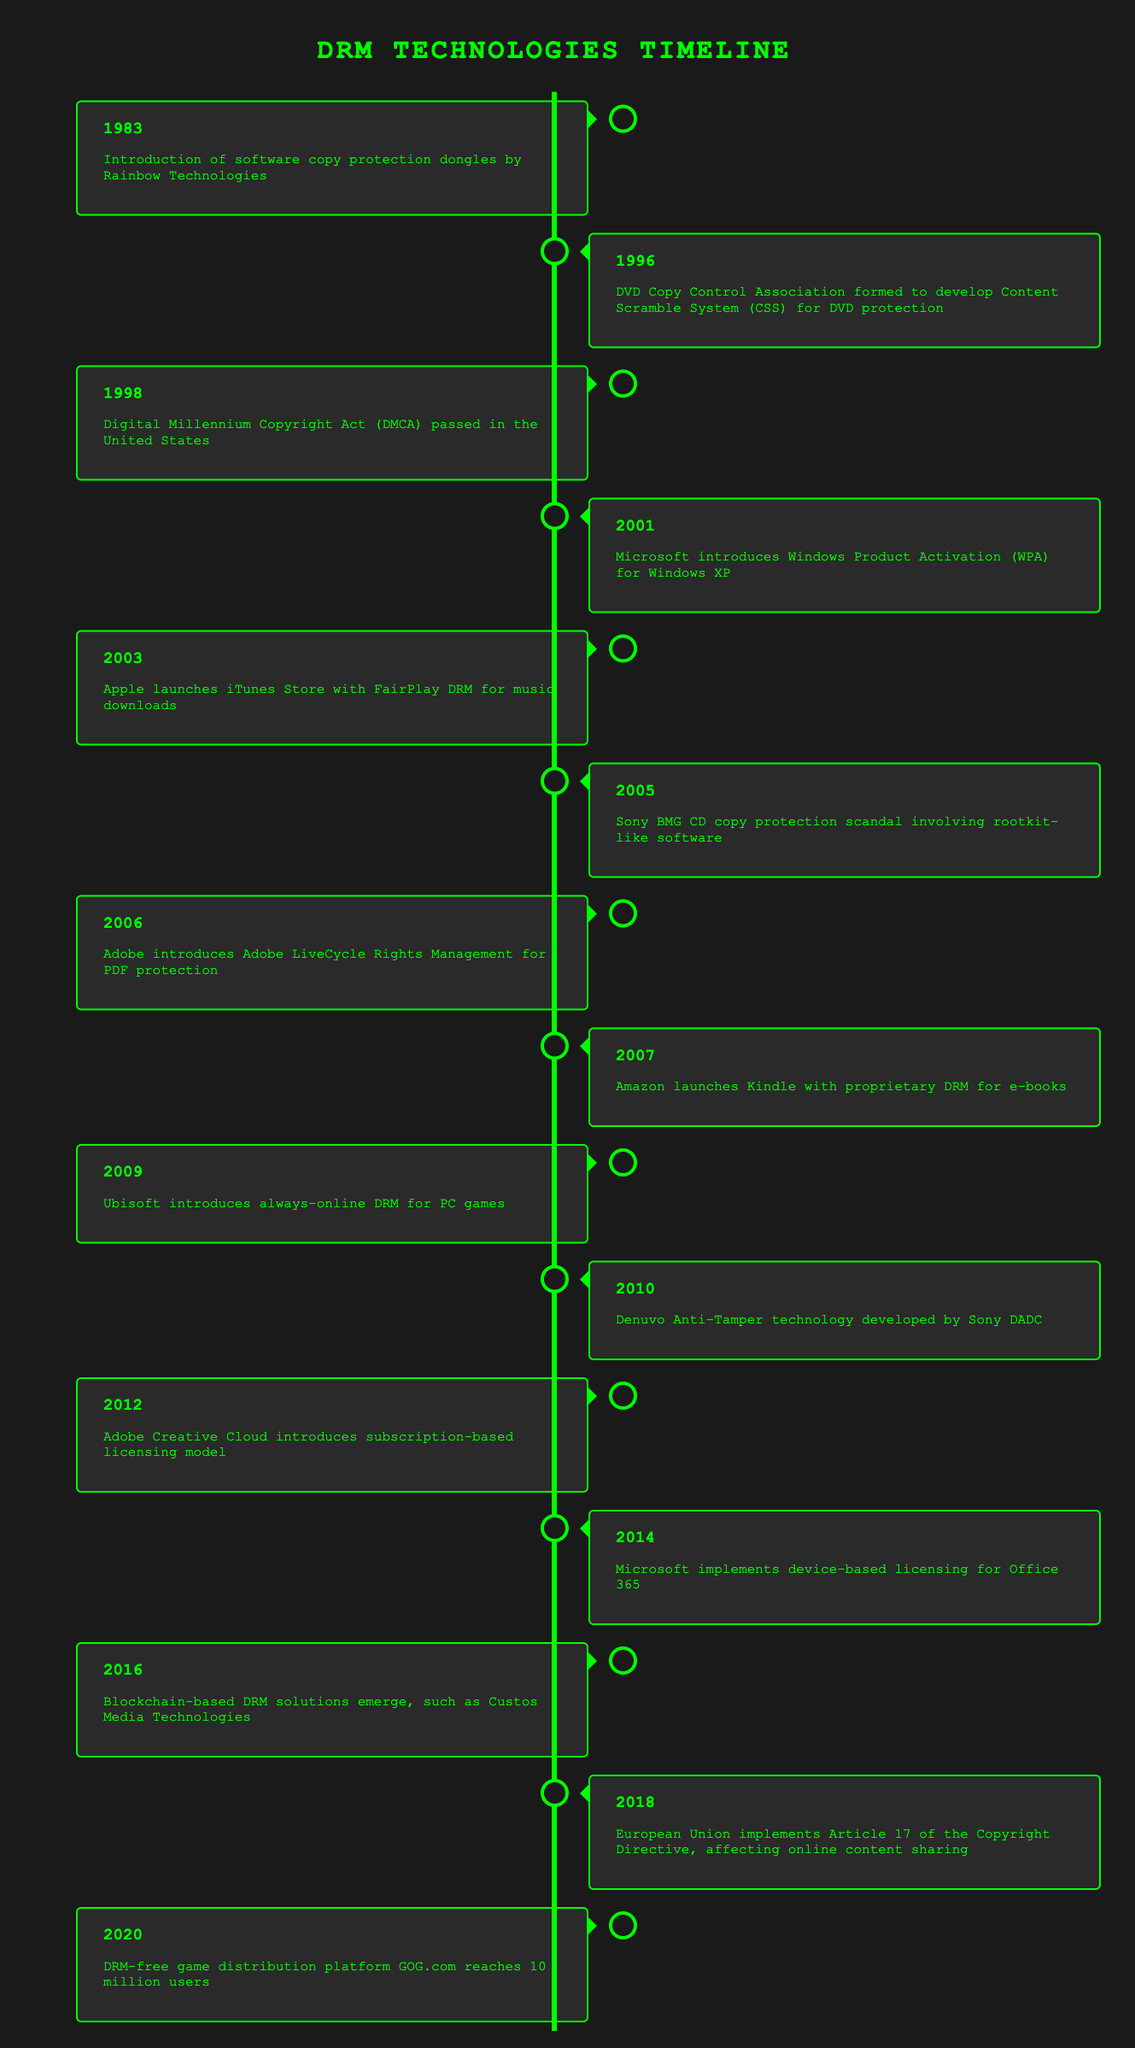What year was the Digital Millennium Copyright Act (DMCA) passed in the United States? The year the DMCA was passed is explicitly stated in the row for that event. It shows 1998 as the year for the event in which the DMCA was enacted, according to the timeline table.
Answer: 1998 What company introduced Windows Product Activation (WPA) for Windows XP? The event describes "Microsoft introduces Windows Product Activation (WPA) for Windows XP" and indicates that Microsoft is the company responsible for this development, as captured in the timeline.
Answer: Microsoft Which event occurred first, the introduction of DRM for e-books by Amazon or the introduction of Adobe LiveCycle Rights Management? Looking at the years associated with the two events, Adobe LiveCycle Rights Management was introduced in 2006 while Amazon’s DRM for e-books was launched in 2007. Since 2006 is earlier than 2007, Adobe's event occurred first.
Answer: Adobe LiveCycle Rights Management How many years passed between the introduction of FairPlay DRM by Apple in 2003 and the launch of the Kindle by Amazon in 2007? To find the number of years between these two events, subtract the earlier year from the later year: 2007 - 2003 = 4. This calculation indicates that 4 years passed between these events.
Answer: 4 Did the European Union's implementation of Article 17 of the Copyright Directive occur before or after GOG.com reached 10 million users? According to the timeline, the European Union implemented Article 17 in 2018, and GOG.com reached 10 million users in 2020. Since 2018 is before 2020, the implementation occurred first.
Answer: Before Which was the last event mentioned in the timeline? The last event in the timeline can be determined by looking for the most recent year. The entry for the year 2020 states "DRM-free game distribution platform GOG.com reaches 10 million users," marking this as the last event in the chronological listing.
Answer: GOG.com reaching 10 million users How many significant events related to DRM were introduced between 2001 and 2014? By extracting events from the timeline between those years: 2001 (Windows Product Activation), 2003 (FairPlay DRM), 2005 (Sony BMG scandal), 2006 (Adobe LiveCycle), 2007 (Kindle DRM), 2009 (Ubisoft always-online DRM), 2010 (Denuvo Anti-Tamper), 2012 (Adobe Creative Cloud), and 2014 (Microsoft Office 365). Counting these gives a total of 9 significant events.
Answer: 9 Is it true that blockchain-based DRM solutions emerged before the introduction of Adobe Creative Cloud? To verify, we check the timeline: Adobe Creative Cloud was introduced in 2012, while blockchain-based solutions appeared in 2016. Since 2012 precedes 2016, the statement is false.
Answer: No What percentage of events listed involve music or music-related technologies? The timeline indicates two events specifically related to music: the launch of the iTunes Store with FairPlay DRM in 2003 and the Sony BMG scandal, which also directly relates to music in 2005. Given the total of 15 events listed, calculate the percentage: (2/15) * 100 = approximately 13.33%.
Answer: 13.33% 